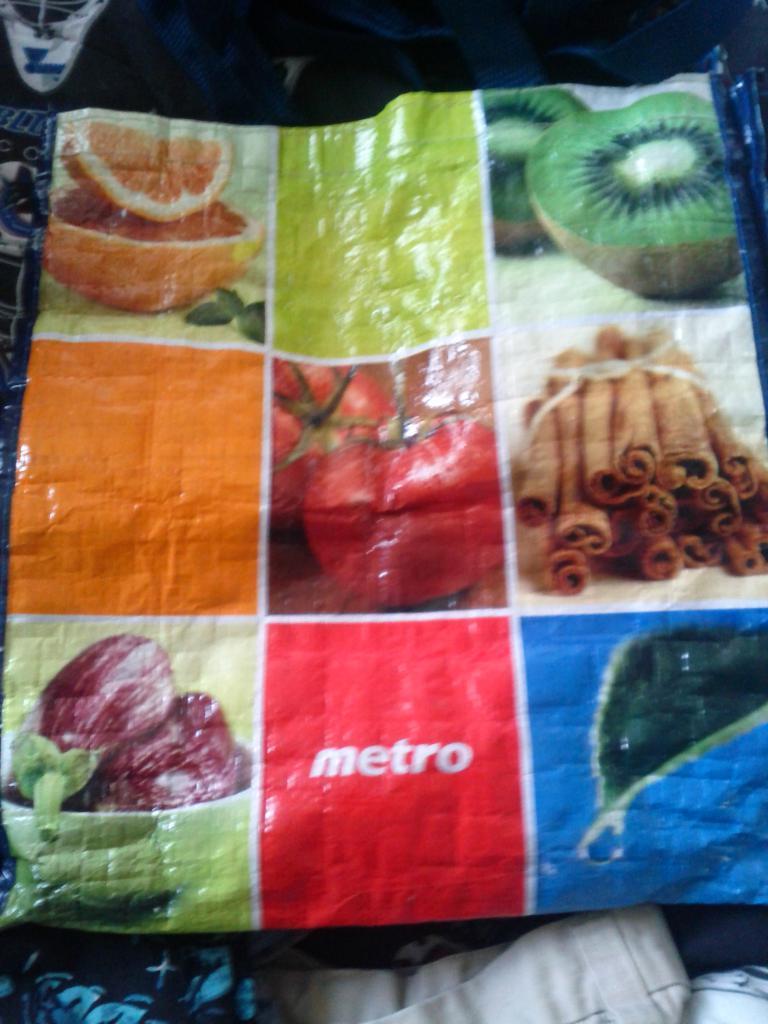Could you give a brief overview of what you see in this image? In this image, we can see a plastic cover and we can see some photos on the cover. 